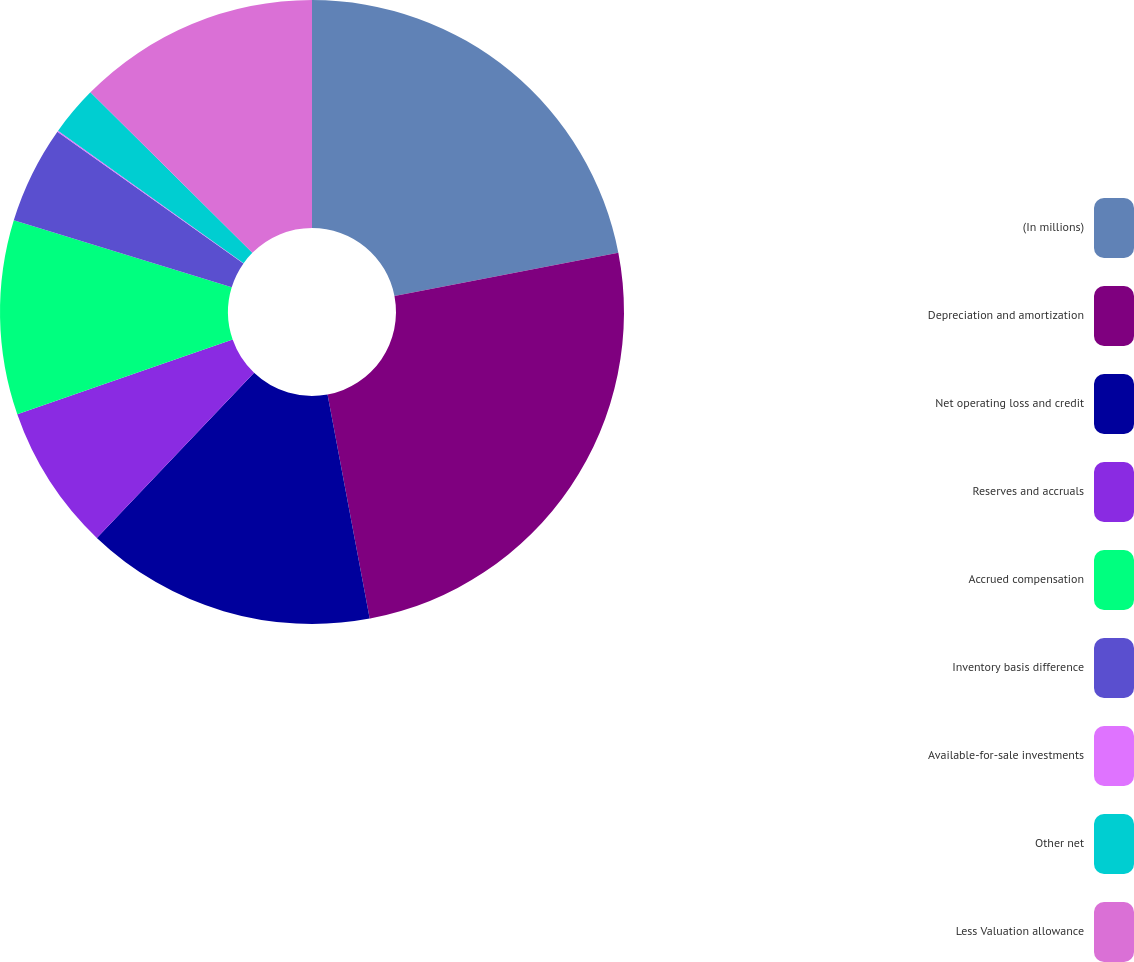Convert chart to OTSL. <chart><loc_0><loc_0><loc_500><loc_500><pie_chart><fcel>(In millions)<fcel>Depreciation and amortization<fcel>Net operating loss and credit<fcel>Reserves and accruals<fcel>Accrued compensation<fcel>Inventory basis difference<fcel>Available-for-sale investments<fcel>Other net<fcel>Less Valuation allowance<nl><fcel>21.96%<fcel>25.08%<fcel>15.07%<fcel>7.57%<fcel>10.07%<fcel>5.06%<fcel>0.06%<fcel>2.56%<fcel>12.57%<nl></chart> 